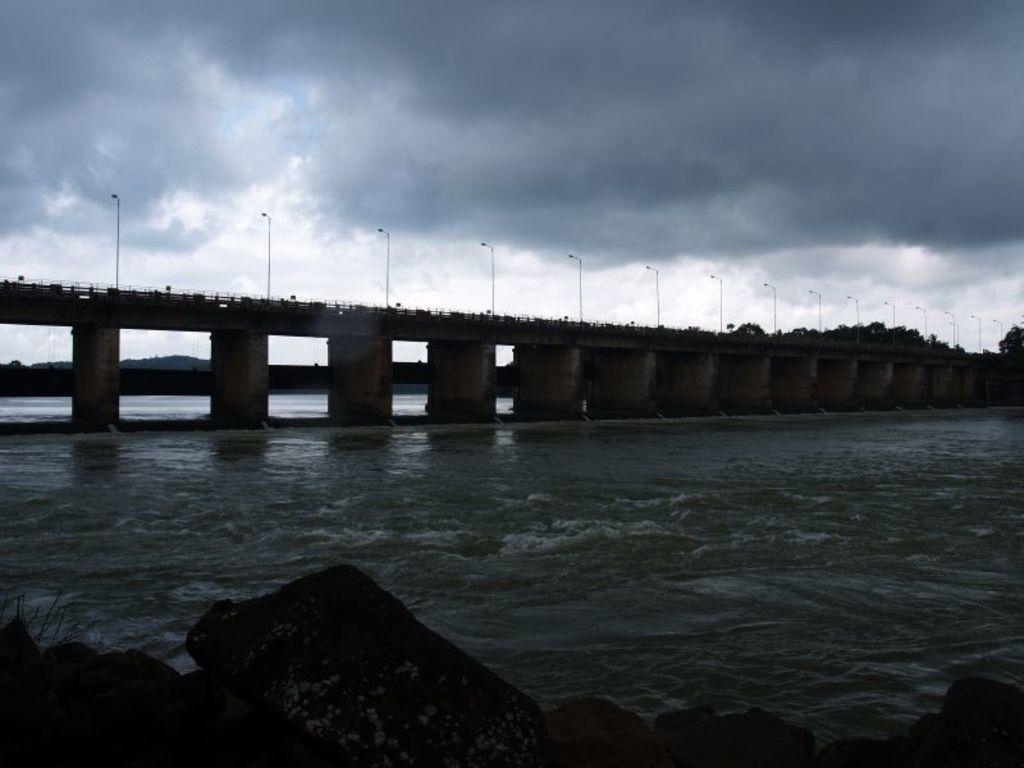In one or two sentences, can you explain what this image depicts? This is an outside view. In this image I can see a sea and also there is a bridge. On the bridge, I can see some poles. At the bottom of the image there are some rocks. On the top of the image I can see the sky and it is cloudy. 